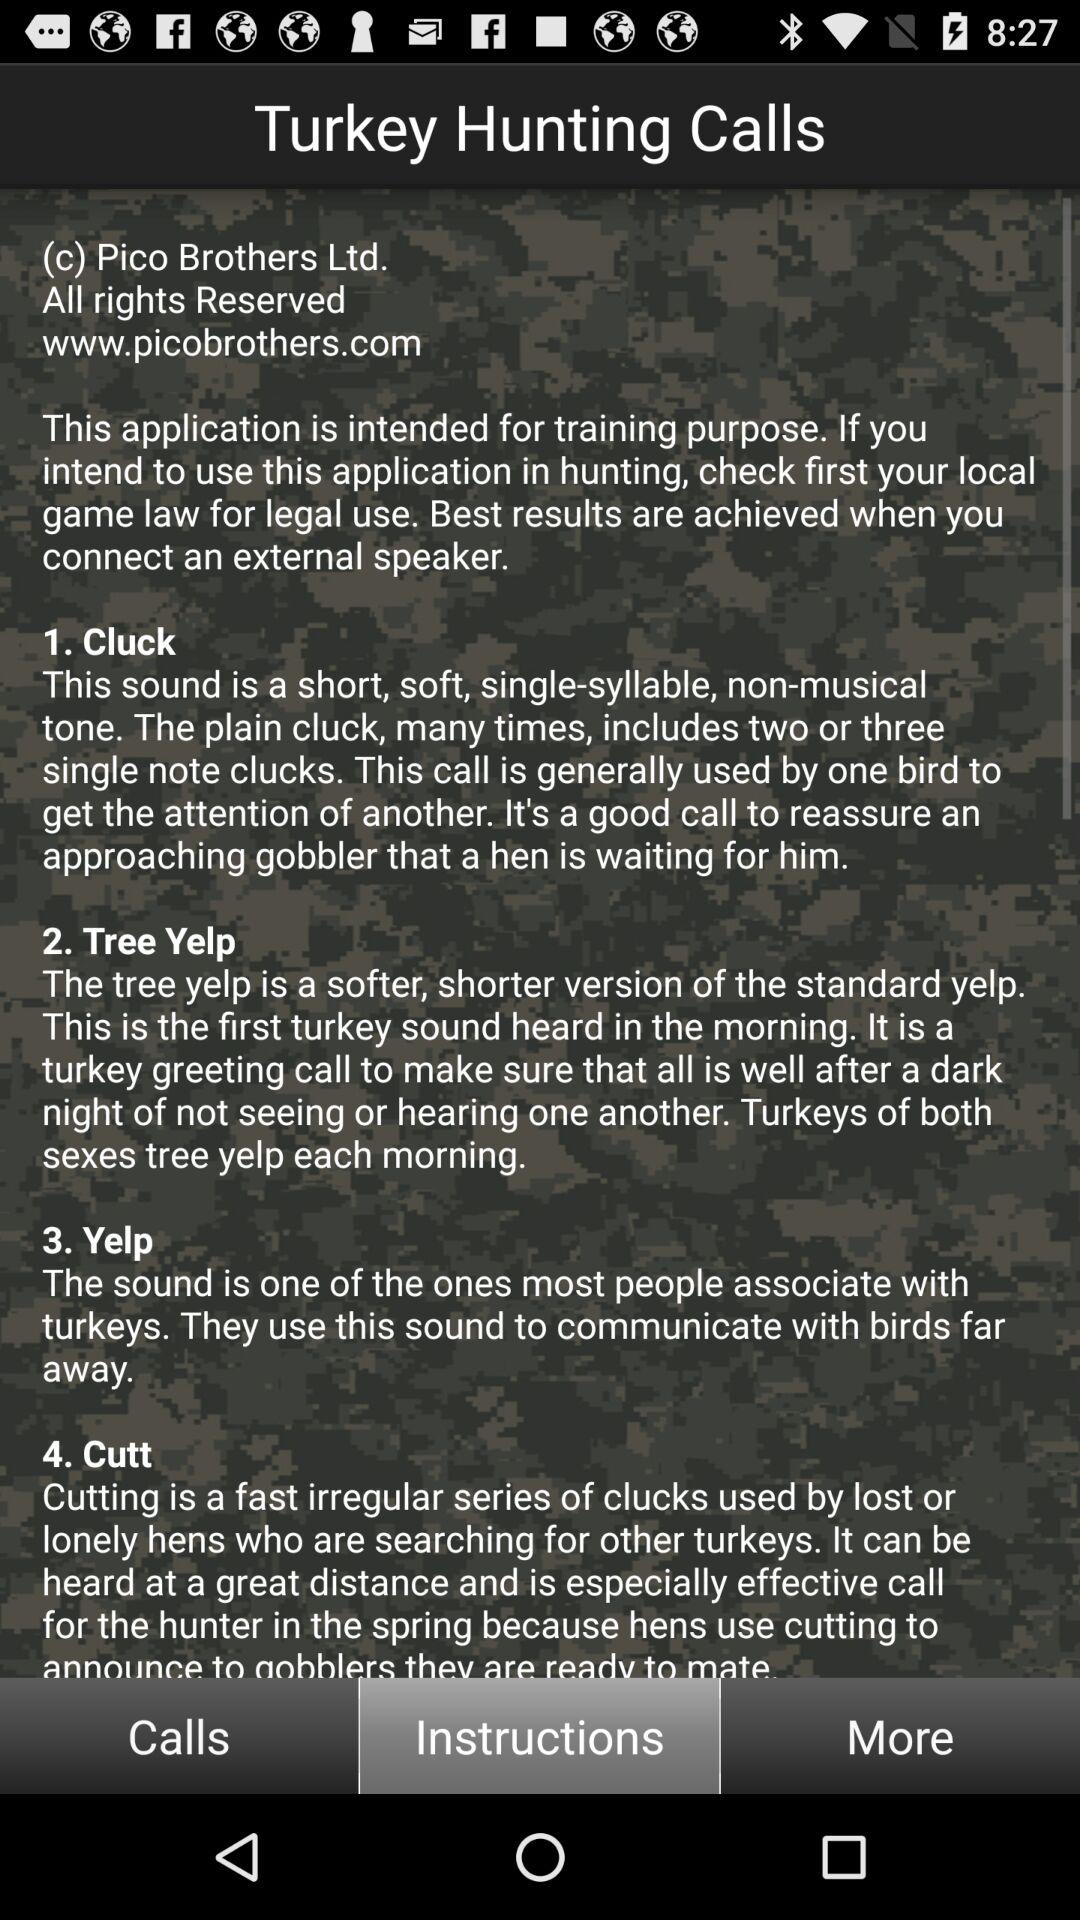How many calls are there in this app?
Answer the question using a single word or phrase. 4 